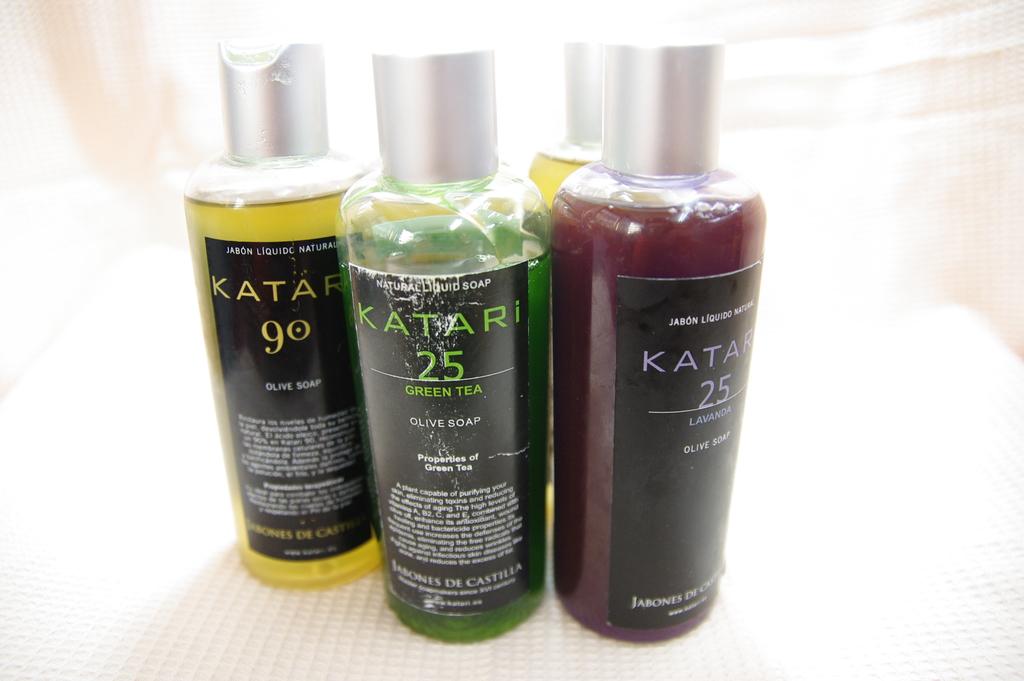What does the right bottle say?
Your answer should be very brief. Katari. 